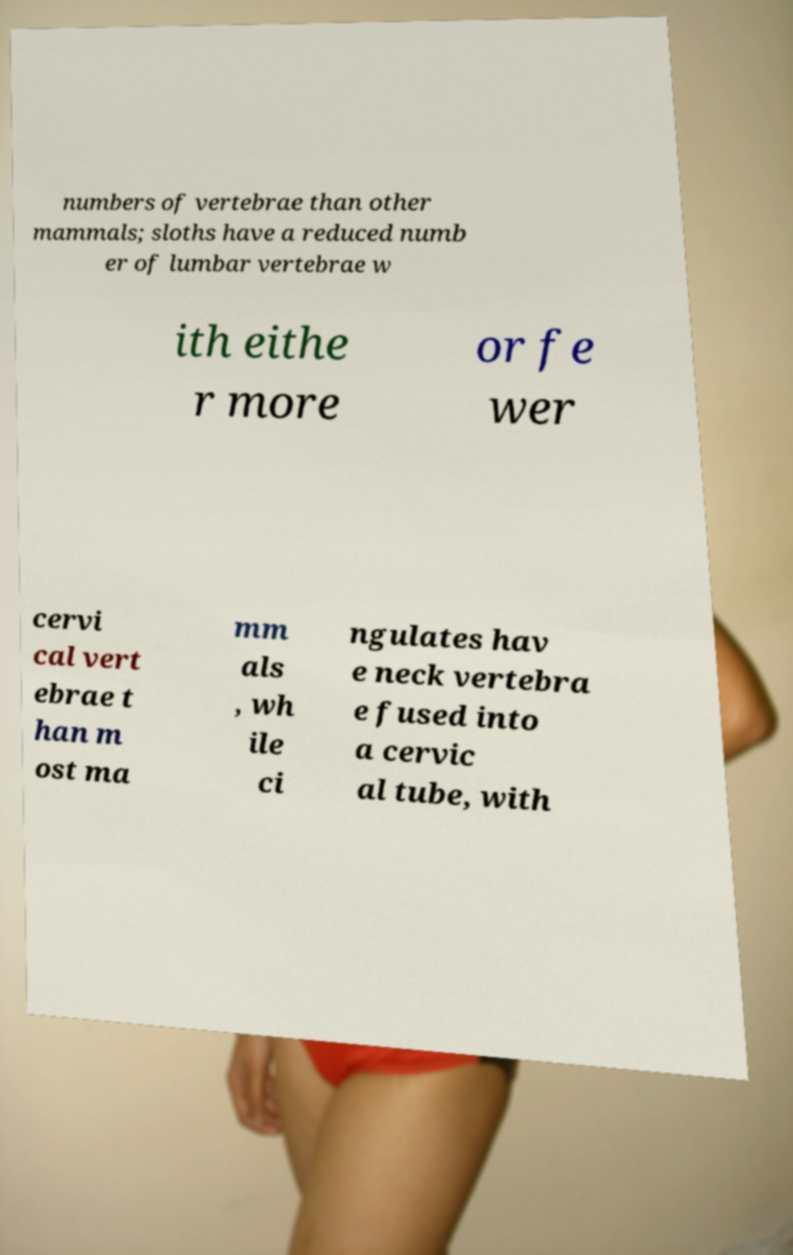Could you assist in decoding the text presented in this image and type it out clearly? numbers of vertebrae than other mammals; sloths have a reduced numb er of lumbar vertebrae w ith eithe r more or fe wer cervi cal vert ebrae t han m ost ma mm als , wh ile ci ngulates hav e neck vertebra e fused into a cervic al tube, with 